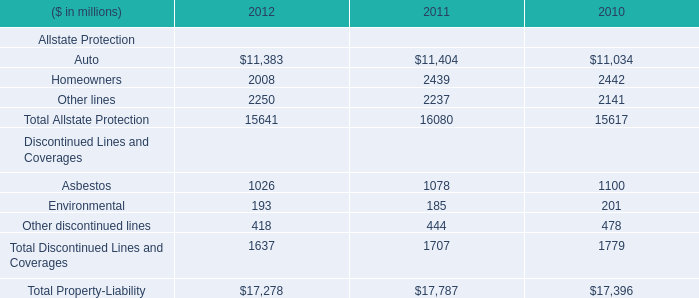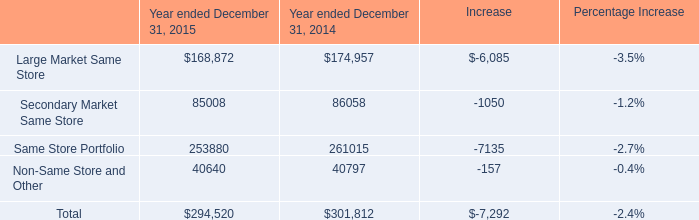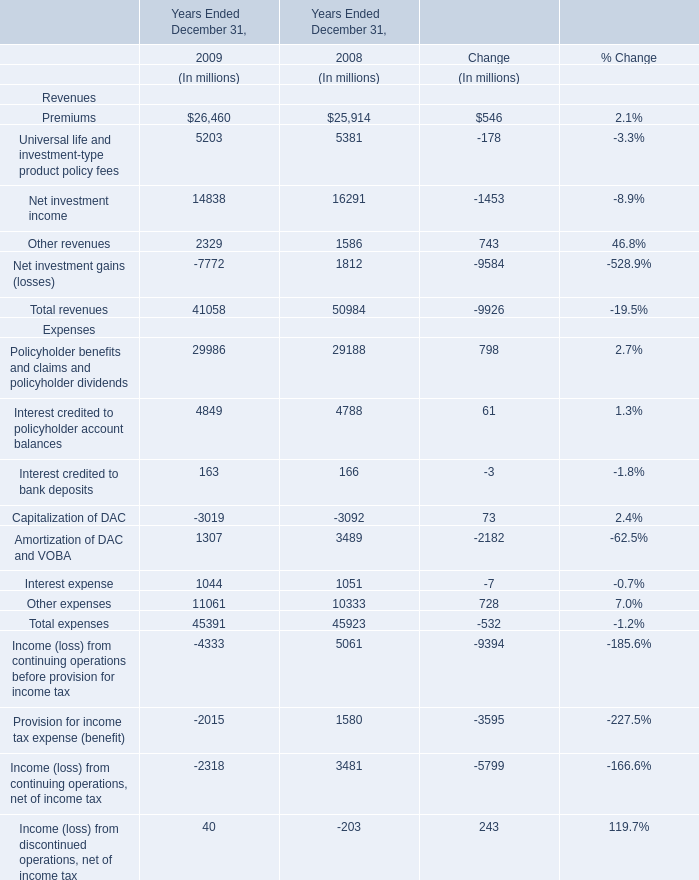What is the sum of Other lines of 2010, and Same Store Portfolio of Year ended December 31, 2015 ? 
Computations: (2141.0 + 253880.0)
Answer: 256021.0. 